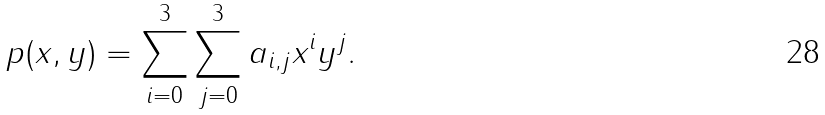<formula> <loc_0><loc_0><loc_500><loc_500>p ( x , y ) = \sum _ { i = 0 } ^ { 3 } \sum _ { j = 0 } ^ { 3 } a _ { i , j } x ^ { i } y ^ { j } .</formula> 